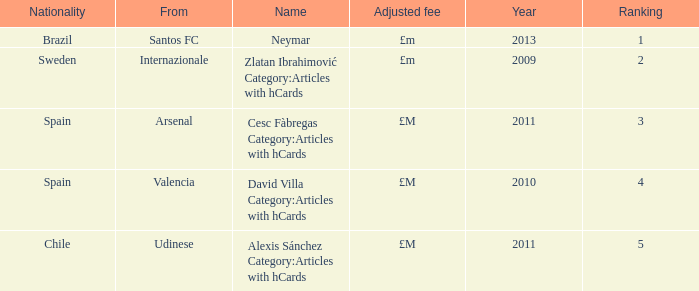What is the name of the player from Spain with a rank lower than 3? David Villa Category:Articles with hCards. 